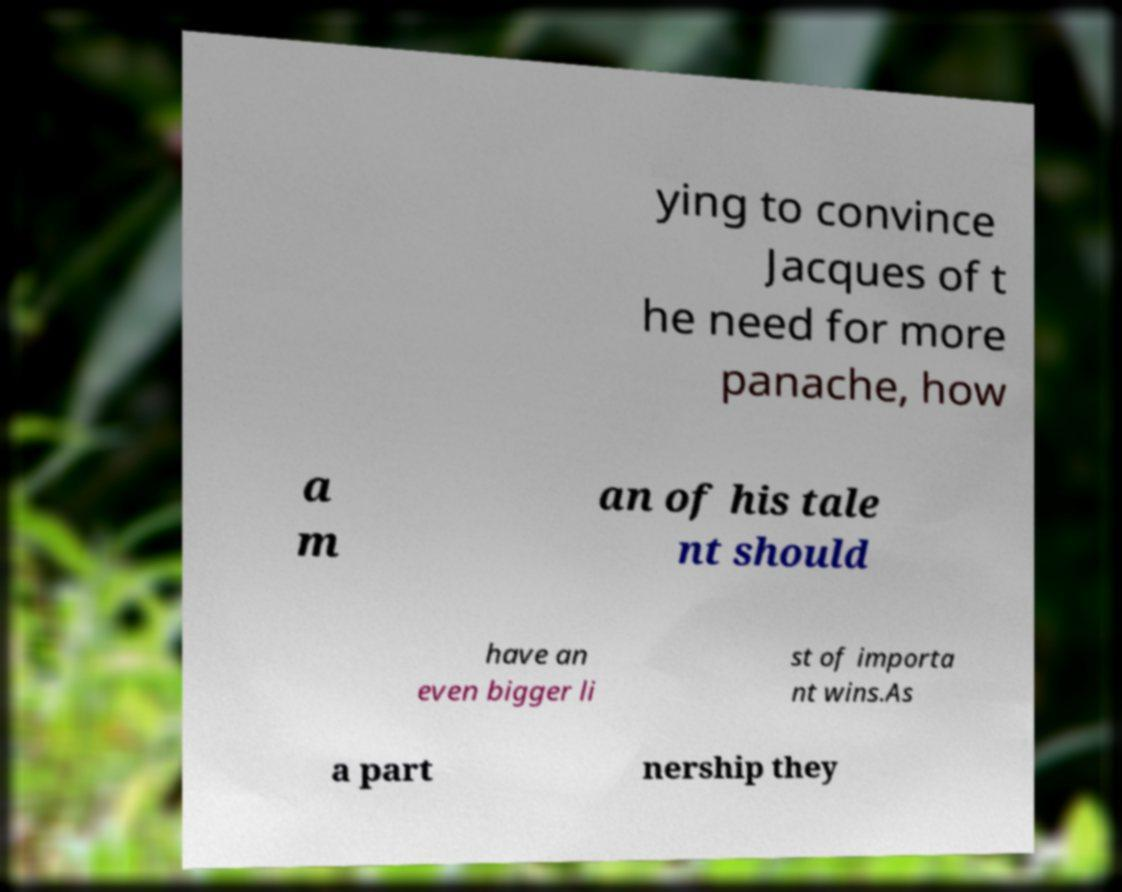For documentation purposes, I need the text within this image transcribed. Could you provide that? ying to convince Jacques of t he need for more panache, how a m an of his tale nt should have an even bigger li st of importa nt wins.As a part nership they 